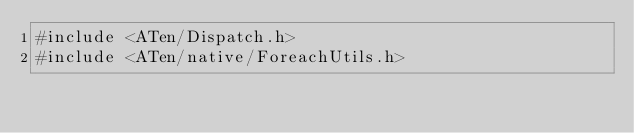<code> <loc_0><loc_0><loc_500><loc_500><_Cuda_>#include <ATen/Dispatch.h>
#include <ATen/native/ForeachUtils.h></code> 